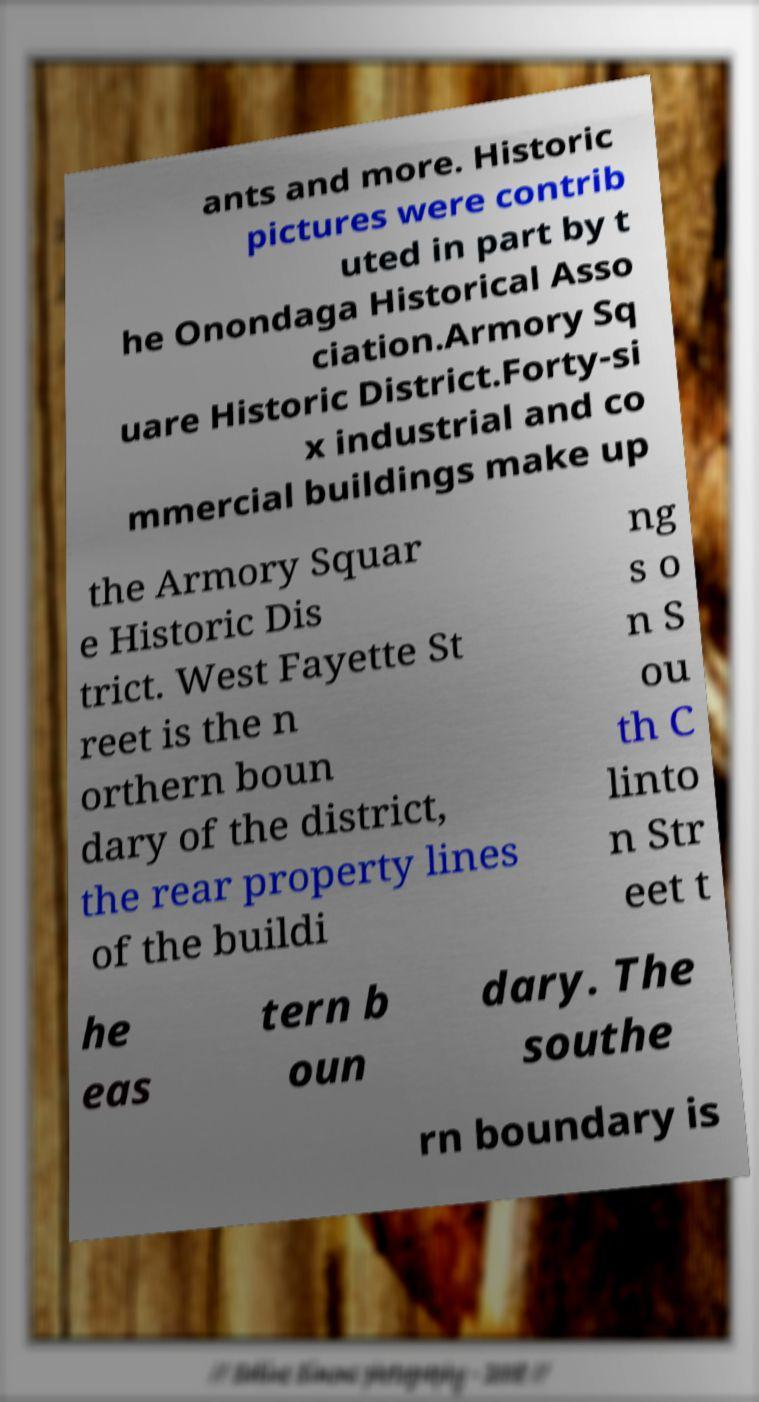There's text embedded in this image that I need extracted. Can you transcribe it verbatim? ants and more. Historic pictures were contrib uted in part by t he Onondaga Historical Asso ciation.Armory Sq uare Historic District.Forty-si x industrial and co mmercial buildings make up the Armory Squar e Historic Dis trict. West Fayette St reet is the n orthern boun dary of the district, the rear property lines of the buildi ng s o n S ou th C linto n Str eet t he eas tern b oun dary. The southe rn boundary is 